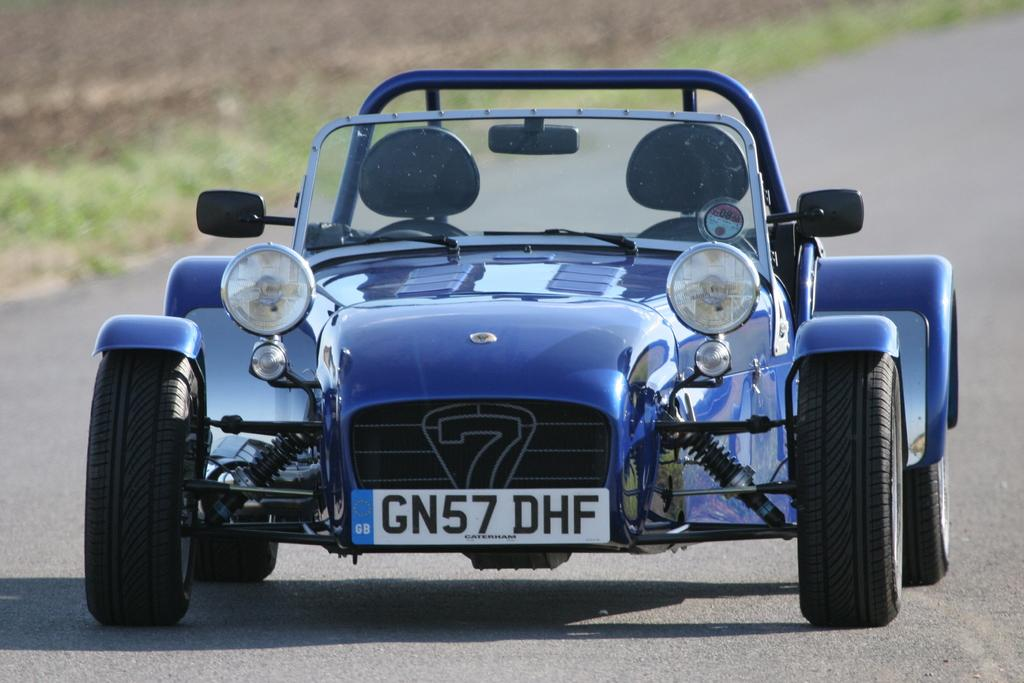What color is the vehicle in the image? The vehicle in the image is blue. Where is the vehicle located? The vehicle is on the road. What type of vegetation can be seen in the image? There is grass visible in the image. Reasoning: Let's think step by step by step in order to produce the conversation. We start by identifying the main subject in the image, which is the blue vehicle. Then, we expand the conversation to include the location of the vehicle and the type of vegetation visible in the image. Each question is designed to elicit a specific detail about the image that is known from the provided facts. Absurd Question/Answer: Can you hear the sound of a guitar being played in the image? There is no mention of a guitar or any sound in the image, so it cannot be determined if a guitar is being played. 